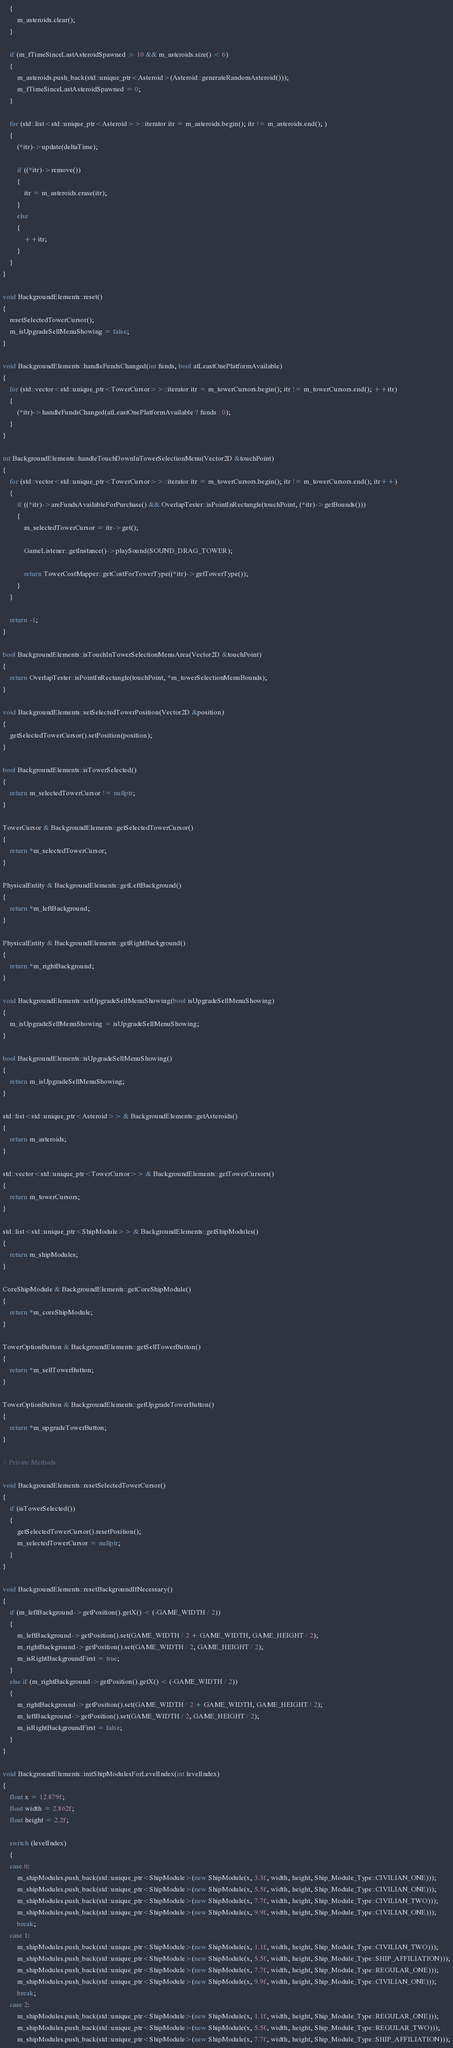<code> <loc_0><loc_0><loc_500><loc_500><_C++_>	{
		m_asteroids.clear();
	}

	if (m_fTimeSinceLastAsteroidSpawned > 10 && m_asteroids.size() < 6)
	{
		m_asteroids.push_back(std::unique_ptr<Asteroid>(Asteroid::generateRandomAsteroid()));
		m_fTimeSinceLastAsteroidSpawned = 0;
	}

	for (std::list<std::unique_ptr<Asteroid>>::iterator itr = m_asteroids.begin(); itr != m_asteroids.end(); )
	{
		(*itr)->update(deltaTime);

		if ((*itr)->remove())
		{
			itr = m_asteroids.erase(itr);
		}
		else
		{
			++itr;
		}
	}
}

void BackgroundElements::reset()
{
	resetSelectedTowerCursor();
	m_isUpgradeSellMenuShowing = false;
}

void BackgroundElements::handleFundsChanged(int funds, bool atLeastOnePlatformAvailable)
{
	for (std::vector<std::unique_ptr<TowerCursor>>::iterator itr = m_towerCursors.begin(); itr != m_towerCursors.end(); ++itr)
	{
		(*itr)->handleFundsChanged(atLeastOnePlatformAvailable ? funds : 0);
	}
}

int BackgroundElements::handleTouchDownInTowerSelectionMenu(Vector2D &touchPoint)
{
	for (std::vector<std::unique_ptr<TowerCursor>>::iterator itr = m_towerCursors.begin(); itr != m_towerCursors.end(); itr++)
	{
		if ((*itr)->areFundsAvailableForPurchase() && OverlapTester::isPointInRectangle(touchPoint, (*itr)->getBounds()))
		{
			m_selectedTowerCursor = itr->get();
            
            GameListener::getInstance()->playSound(SOUND_DRAG_TOWER);
            
			return TowerCostMapper::getCostForTowerType((*itr)->getTowerType());
		}
	}

	return -1;
}

bool BackgroundElements::isTouchInTowerSelectionMenuArea(Vector2D &touchPoint)
{
	return OverlapTester::isPointInRectangle(touchPoint, *m_towerSelectionMenuBounds);
}

void BackgroundElements::setSelectedTowerPosition(Vector2D &position)
{
	getSelectedTowerCursor().setPosition(position);
}

bool BackgroundElements::isTowerSelected()
{
	return m_selectedTowerCursor != nullptr;
}

TowerCursor & BackgroundElements::getSelectedTowerCursor()
{
	return *m_selectedTowerCursor;
}

PhysicalEntity & BackgroundElements::getLeftBackground()
{
	return *m_leftBackground;
}

PhysicalEntity & BackgroundElements::getRightBackground()
{
	return *m_rightBackground;
}

void BackgroundElements::setUpgradeSellMenuShowing(bool isUpgradeSellMenuShowing)
{
	m_isUpgradeSellMenuShowing = isUpgradeSellMenuShowing;
}

bool BackgroundElements::isUpgradeSellMenuShowing()
{
	return m_isUpgradeSellMenuShowing;
}

std::list<std::unique_ptr<Asteroid>> & BackgroundElements::getAsteroids()
{
	return m_asteroids;
}

std::vector<std::unique_ptr<TowerCursor>> & BackgroundElements::getTowerCursors()
{
	return m_towerCursors;
}

std::list<std::unique_ptr<ShipModule>> & BackgroundElements::getShipModules()
{
	return m_shipModules;
}

CoreShipModule & BackgroundElements::getCoreShipModule()
{
	return *m_coreShipModule;
}

TowerOptionButton & BackgroundElements::getSellTowerButton()
{
	return *m_sellTowerButton;
}

TowerOptionButton & BackgroundElements::getUpgradeTowerButton()
{
	return *m_upgradeTowerButton;
}

// Private Methods

void BackgroundElements::resetSelectedTowerCursor()
{
	if (isTowerSelected())
	{
		getSelectedTowerCursor().resetPosition();
		m_selectedTowerCursor = nullptr;
	}
}

void BackgroundElements::resetBackgroundIfNecessary()
{
	if (m_leftBackground->getPosition().getX() < (-GAME_WIDTH / 2))
	{
		m_leftBackground->getPosition().set(GAME_WIDTH / 2 + GAME_WIDTH, GAME_HEIGHT / 2);
		m_rightBackground->getPosition().set(GAME_WIDTH / 2, GAME_HEIGHT / 2);
		m_isRightBackgroundFirst = true;
	}
	else if (m_rightBackground->getPosition().getX() < (-GAME_WIDTH / 2))
	{
		m_rightBackground->getPosition().set(GAME_WIDTH / 2 + GAME_WIDTH, GAME_HEIGHT / 2);
		m_leftBackground->getPosition().set(GAME_WIDTH / 2, GAME_HEIGHT / 2);
		m_isRightBackgroundFirst = false;
	}
}

void BackgroundElements::initShipModulesForLevelIndex(int levelIndex)
{
	float x = 12.879f;
	float width = 2.862f;
	float height = 2.2f;

	switch (levelIndex)
	{
	case 0:
		m_shipModules.push_back(std::unique_ptr<ShipModule>(new ShipModule(x, 3.3f, width, height, Ship_Module_Type::CIVILIAN_ONE)));
		m_shipModules.push_back(std::unique_ptr<ShipModule>(new ShipModule(x, 5.5f, width, height, Ship_Module_Type::CIVILIAN_ONE)));
		m_shipModules.push_back(std::unique_ptr<ShipModule>(new ShipModule(x, 7.7f, width, height, Ship_Module_Type::CIVILIAN_TWO)));
		m_shipModules.push_back(std::unique_ptr<ShipModule>(new ShipModule(x, 9.9f, width, height, Ship_Module_Type::CIVILIAN_ONE)));
		break;
	case 1:
		m_shipModules.push_back(std::unique_ptr<ShipModule>(new ShipModule(x, 1.1f, width, height, Ship_Module_Type::CIVILIAN_TWO)));
		m_shipModules.push_back(std::unique_ptr<ShipModule>(new ShipModule(x, 5.5f, width, height, Ship_Module_Type::SHIP_AFFILIATION)));
		m_shipModules.push_back(std::unique_ptr<ShipModule>(new ShipModule(x, 7.7f, width, height, Ship_Module_Type::REGULAR_ONE)));
		m_shipModules.push_back(std::unique_ptr<ShipModule>(new ShipModule(x, 9.9f, width, height, Ship_Module_Type::CIVILIAN_ONE)));
		break;
	case 2:
		m_shipModules.push_back(std::unique_ptr<ShipModule>(new ShipModule(x, 1.1f, width, height, Ship_Module_Type::REGULAR_ONE)));
		m_shipModules.push_back(std::unique_ptr<ShipModule>(new ShipModule(x, 5.5f, width, height, Ship_Module_Type::REGULAR_TWO)));
		m_shipModules.push_back(std::unique_ptr<ShipModule>(new ShipModule(x, 7.7f, width, height, Ship_Module_Type::SHIP_AFFILIATION)));</code> 